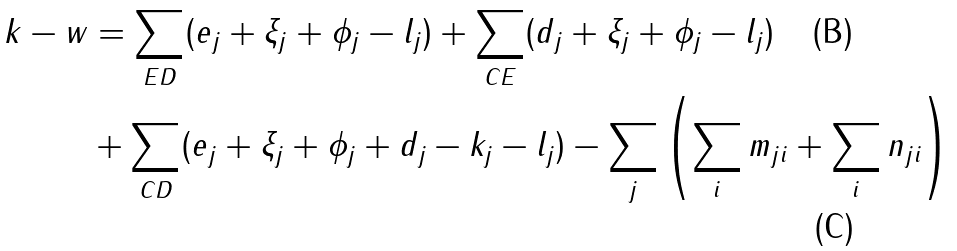Convert formula to latex. <formula><loc_0><loc_0><loc_500><loc_500>k - w & = \sum _ { E D } ( e _ { j } + \xi _ { j } + \phi _ { j } - l _ { j } ) + \sum _ { C E } ( d _ { j } + \xi _ { j } + \phi _ { j } - l _ { j } ) \\ & + \sum _ { C D } ( e _ { j } + \xi _ { j } + \phi _ { j } + d _ { j } - k _ { j } - l _ { j } ) - \sum _ { j } \left ( \sum _ { i } m _ { j i } + \sum _ { i } n _ { j i } \right )</formula> 